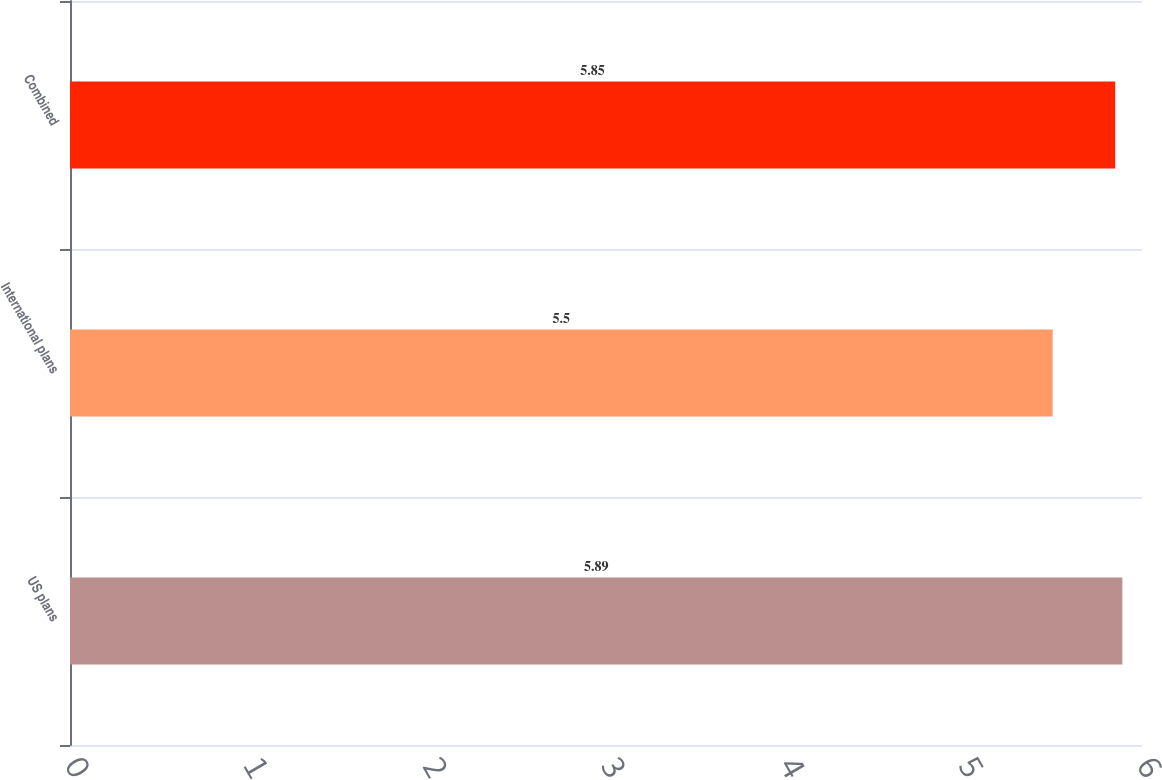Convert chart to OTSL. <chart><loc_0><loc_0><loc_500><loc_500><bar_chart><fcel>US plans<fcel>International plans<fcel>Combined<nl><fcel>5.89<fcel>5.5<fcel>5.85<nl></chart> 